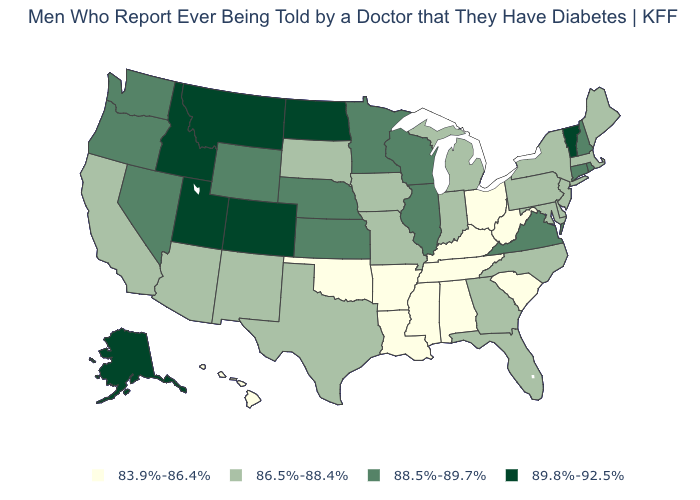Name the states that have a value in the range 88.5%-89.7%?
Be succinct. Connecticut, Illinois, Kansas, Minnesota, Nebraska, Nevada, New Hampshire, Oregon, Rhode Island, Virginia, Washington, Wisconsin, Wyoming. What is the value of Louisiana?
Quick response, please. 83.9%-86.4%. How many symbols are there in the legend?
Short answer required. 4. Name the states that have a value in the range 83.9%-86.4%?
Short answer required. Alabama, Arkansas, Hawaii, Kentucky, Louisiana, Mississippi, Ohio, Oklahoma, South Carolina, Tennessee, West Virginia. How many symbols are there in the legend?
Quick response, please. 4. What is the highest value in states that border Colorado?
Concise answer only. 89.8%-92.5%. Name the states that have a value in the range 88.5%-89.7%?
Be succinct. Connecticut, Illinois, Kansas, Minnesota, Nebraska, Nevada, New Hampshire, Oregon, Rhode Island, Virginia, Washington, Wisconsin, Wyoming. What is the value of Texas?
Answer briefly. 86.5%-88.4%. What is the lowest value in states that border New York?
Answer briefly. 86.5%-88.4%. Does Arkansas have the lowest value in the USA?
Write a very short answer. Yes. Does the map have missing data?
Keep it brief. No. Does Missouri have the lowest value in the MidWest?
Keep it brief. No. Does Louisiana have the highest value in the USA?
Be succinct. No. Which states have the lowest value in the MidWest?
Be succinct. Ohio. What is the value of Alabama?
Write a very short answer. 83.9%-86.4%. 